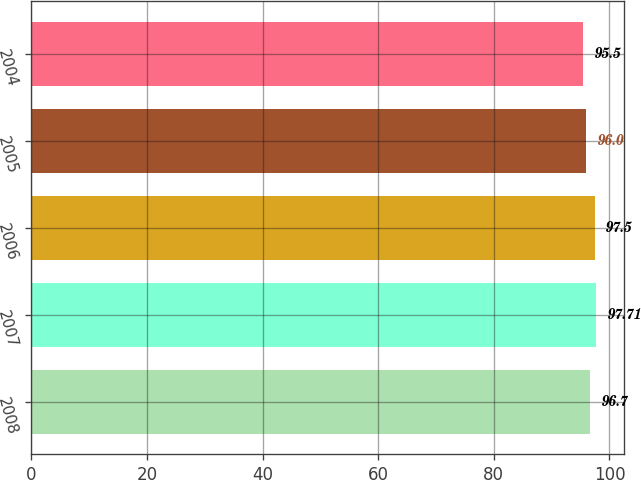Convert chart. <chart><loc_0><loc_0><loc_500><loc_500><bar_chart><fcel>2008<fcel>2007<fcel>2006<fcel>2005<fcel>2004<nl><fcel>96.7<fcel>97.71<fcel>97.5<fcel>96<fcel>95.5<nl></chart> 